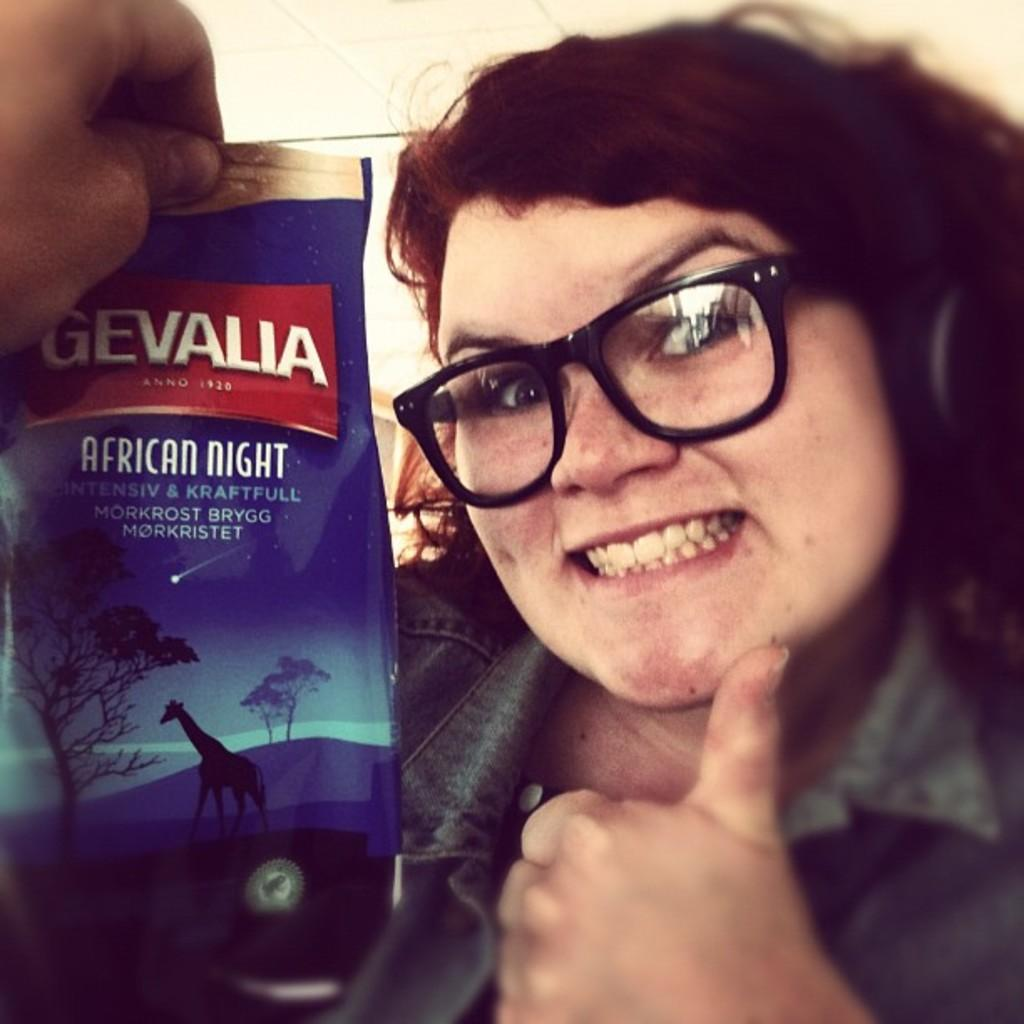Who is present in the image? There is a woman in the image. What is the woman doing in the image? The woman is smiling in the image. What is the woman wearing in the image? The woman is wearing spectacles in the image. What can be seen in front of the woman in the image? There is a hand holding a packet in front of the woman. What is the color of the background in the image? The background of the image is cream-colored. What type of drug can be seen in the woman's hand in the image? There is no drug present in the image; the woman's hand is holding a packet. Can you tell me how many wings are visible in the image? There are no wings visible in the image. 